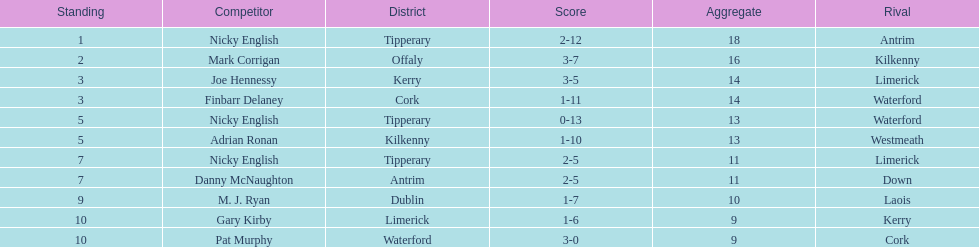Parse the table in full. {'header': ['Standing', 'Competitor', 'District', 'Score', 'Aggregate', 'Rival'], 'rows': [['1', 'Nicky English', 'Tipperary', '2-12', '18', 'Antrim'], ['2', 'Mark Corrigan', 'Offaly', '3-7', '16', 'Kilkenny'], ['3', 'Joe Hennessy', 'Kerry', '3-5', '14', 'Limerick'], ['3', 'Finbarr Delaney', 'Cork', '1-11', '14', 'Waterford'], ['5', 'Nicky English', 'Tipperary', '0-13', '13', 'Waterford'], ['5', 'Adrian Ronan', 'Kilkenny', '1-10', '13', 'Westmeath'], ['7', 'Nicky English', 'Tipperary', '2-5', '11', 'Limerick'], ['7', 'Danny McNaughton', 'Antrim', '2-5', '11', 'Down'], ['9', 'M. J. Ryan', 'Dublin', '1-7', '10', 'Laois'], ['10', 'Gary Kirby', 'Limerick', '1-6', '9', 'Kerry'], ['10', 'Pat Murphy', 'Waterford', '3-0', '9', 'Cork']]} What is the least total on the list? 9. 